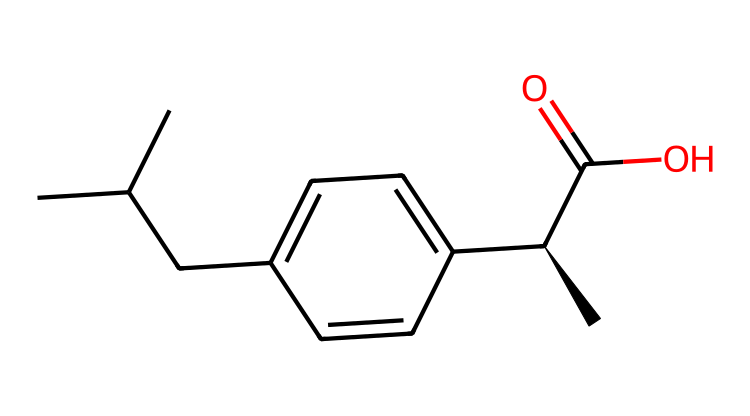What is the IUPAC name of this compound? By interpreting the SMILES representation, we can identify the structure and functional groups present, leading to the systematic naming. The structure reveals a propionic acid derivative with a phenyl group and two isopropyl groups. Thus, the complete IUPAC name is 2-(4-isobutylphenyl)propanoic acid.
Answer: 2-(4-isobutylphenyl)propanoic acid How many carbon atoms are in this compound? Analyzing the SMILES, we can count the carbon atoms represented by "C". Each 'C' signifies a carbon atom, and by systematically counting each segment in the structure, we determine a total of 13 carbon atoms.
Answer: 13 What type of functional group is present in this molecule? The SMILES indicates the presence of a carboxylic acid group, which is shown by "C(=O)O". This indicates a carbon atom bonded to a hydroxyl group and has a double bond with another oxygen atom, confirming the presence of a carboxylic acid functional group.
Answer: carboxylic acid How many chiral centers are in ibuprofen? In the chemical structure given, we identify the chiral center at the carbon connected to the carboxylic acid and adjacent to the methyl group (this is indicated by the notation "[C@H]"). By examining the surrounding groups, we conclude that there is one chiral center in ibuprofen.
Answer: 1 What is the molecular formula of ibuprofen? From the structural interpretation, we can combine the counts of each type of atom found in the compound. The analysis reveals 13 carbon, 18 hydrogen, and 2 oxygen atoms. Thus, the molecular formula is C13H18O2.
Answer: C13H18O2 Does ibuprofen contain any rings in its structure? Examining the SMILES representation, there are no symbols indicating a cyclic structure or atoms bonded in such a way that would form a ring. The entire structure is linear with connected functional groups, hence confirming there are no rings present.
Answer: No 